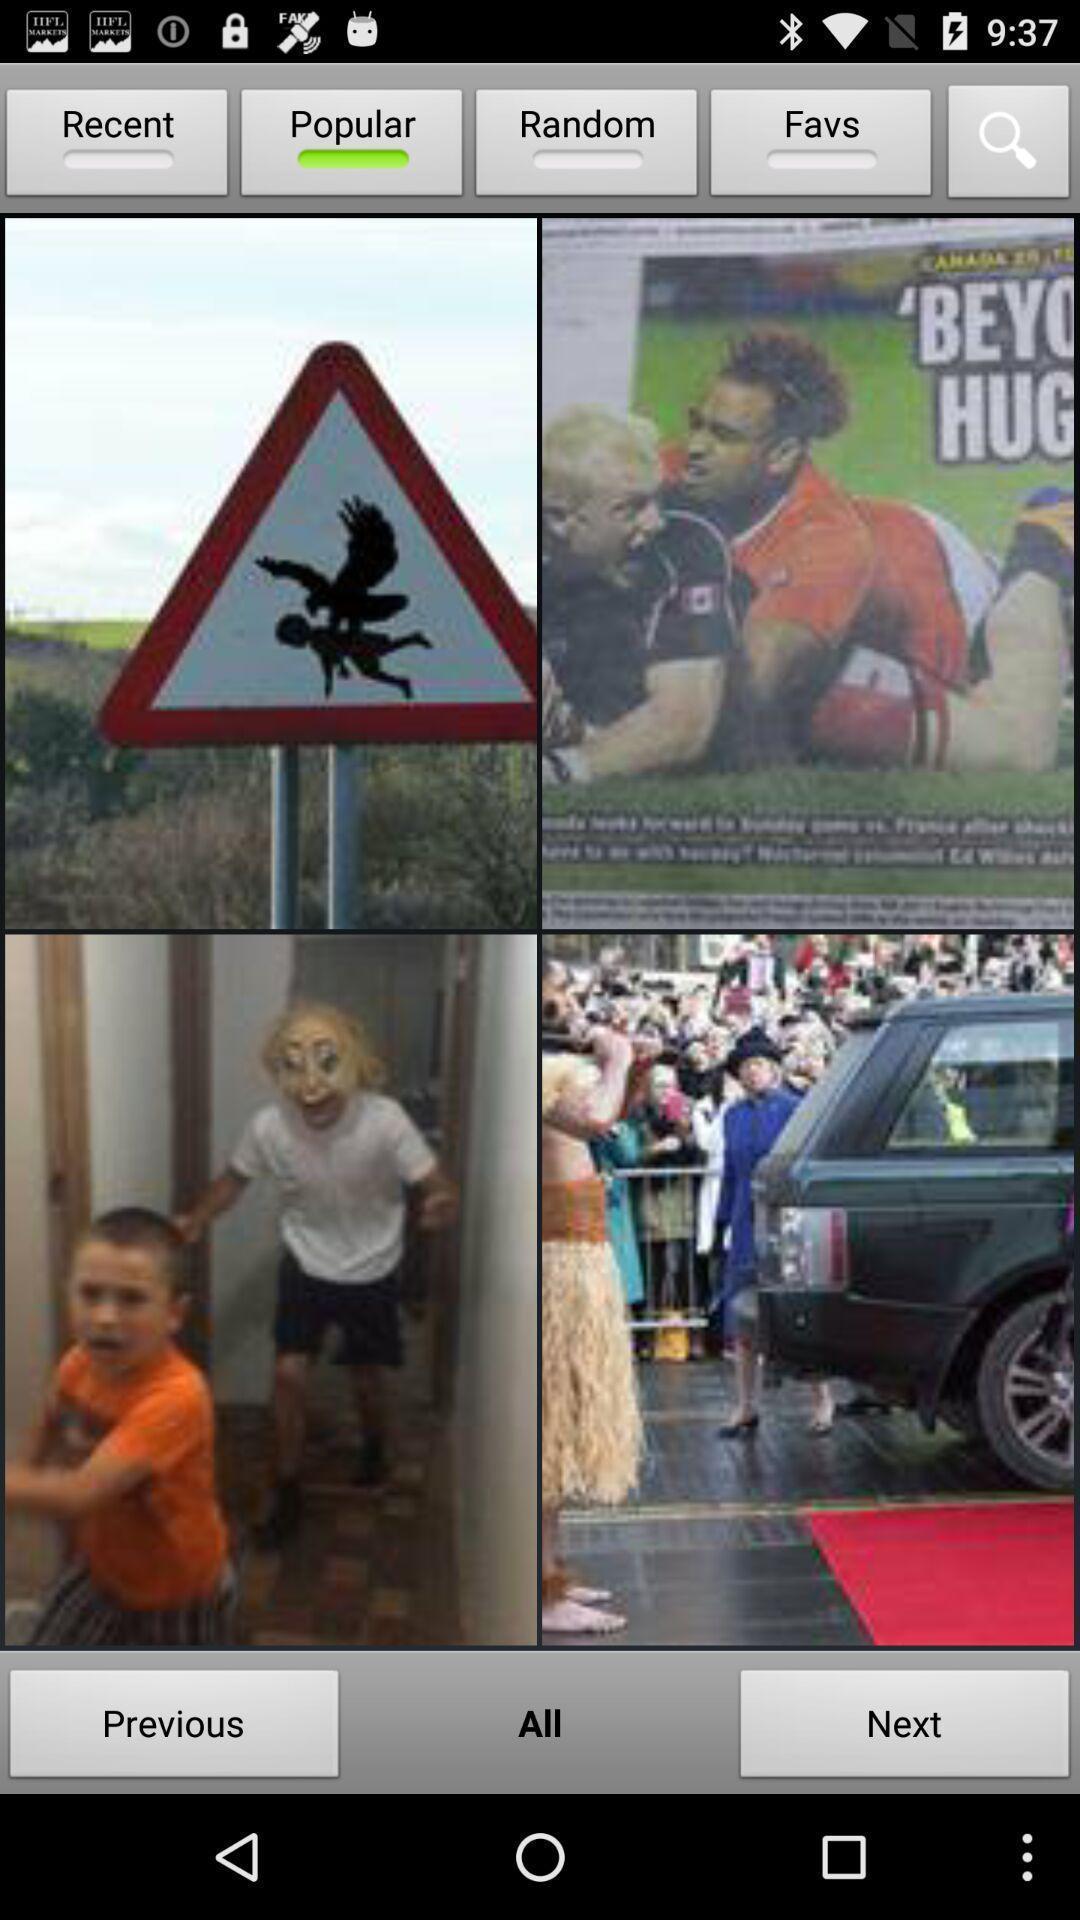Summarize the information in this screenshot. Various image displayed. 